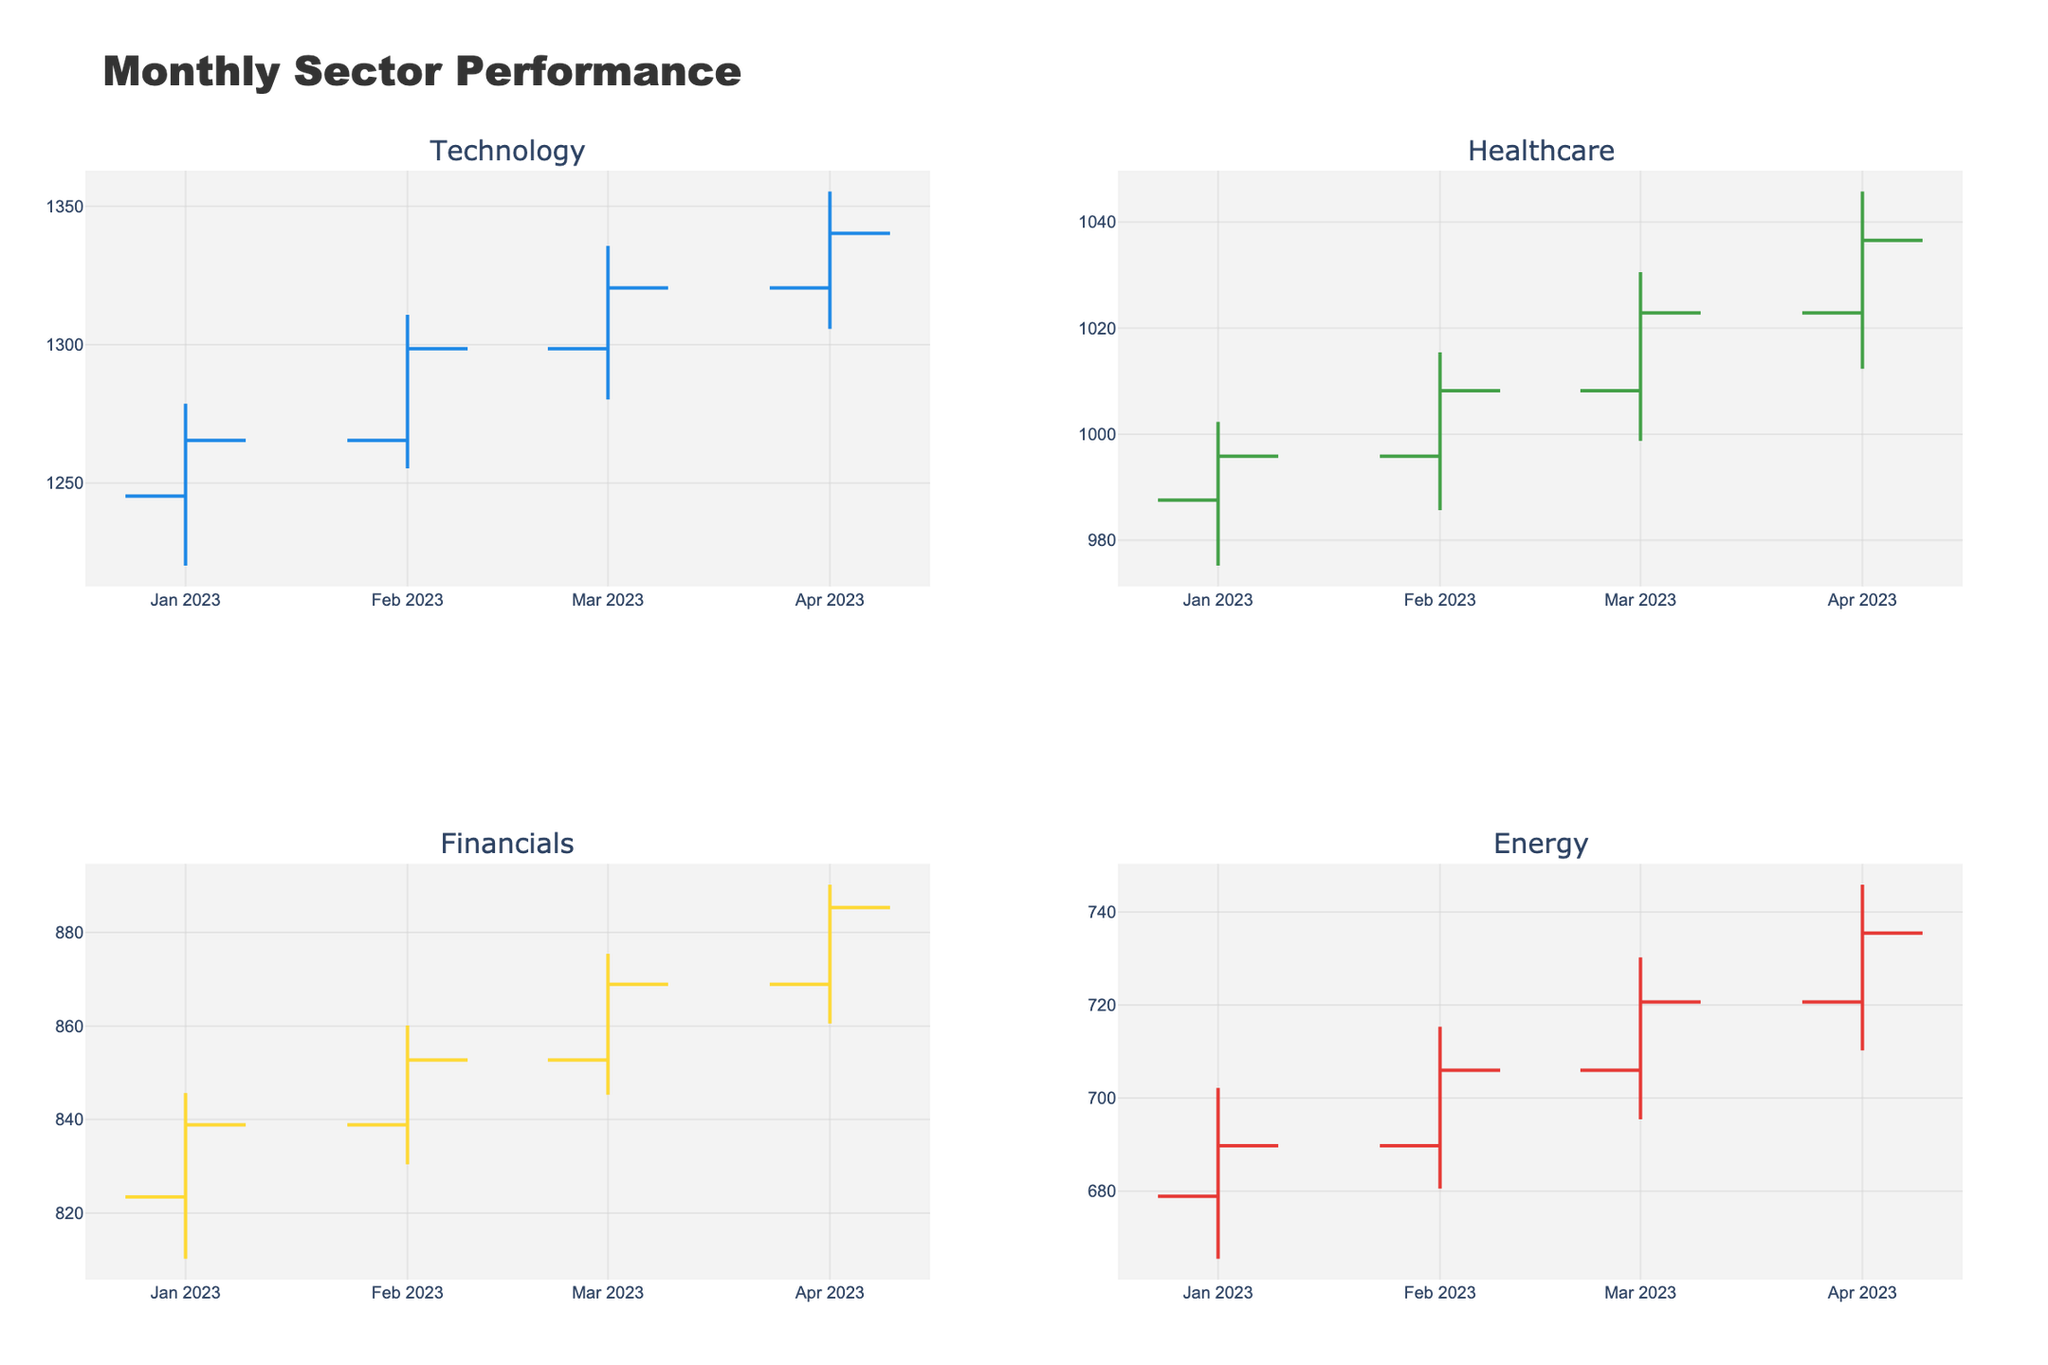What is the title of the figure? The title is located at the top of the figure inside the title text box. It is labeled as "Monthly Sector Performance".
Answer: Monthly Sector Performance Which sector has the highest closing price in April 2023? By examining the closing prices for all sectors in April 2023, one can see the highest closing price among "Technology," "Healthcare," "Financials," and "Energy". The highest is for Technology at 1340.21.
Answer: Technology How many sectors are shown in the figure? The figure is divided into four subplots, each labeled with a sector: "Technology", "Healthcare", "Financials", and "Energy".
Answer: 4 Which sector had a higher opening price in March 2023, Financials or Energy? By comparing the opening prices of Financials (852.76) and Energy (705.98) in March 2023, Financials had a higher opening price.
Answer: Financials What was the closing price for Technology in February 2023? February 2023 Technology data indicates closing prices. For this date, the closing price is 1298.54.
Answer: 1298.54 Which sector showed the greatest increase from its March close to April close? To find this, calculate the difference between March and April closing prices for each sector: Technology (19.76), Healthcare (13.67), Financials (16.42), and Energy (14.78). The greatest increase was seen in Technology.
Answer: Technology What was the lowest price reached by Healthcare in January 2023? For January 2023 in the Healthcare subplot, the lowest price is shown as 975.21.
Answer: 975.21 Analyze if any sector ended consistently on a higher closing price each month from January to April 2023. Examine closing prices for each sector across all months. Technology consistently ended with higher closing prices each month: Jan (1265.43), Feb (1298.54), Mar (1320.45), and Apr (1340.21).
Answer: Technology Which sector's plot has the most significant color difference between increasing and decreasing lines? Looking at sector colors, Technology has a clear blue for increasing and gray for decreasing, standing out strongly. Colors for other sectors vary less prominently.
Answer: Technology What is the average closing price for Energy from January to April 2023? To get the average closing price, sum Energy's monthly closing prices (689.76, 705.98, 720.65, and 735.43) and divide by 4: (689.76 + 705.98 + 720.65 + 735.43) / 4 = 712.455.
Answer: 712.455 